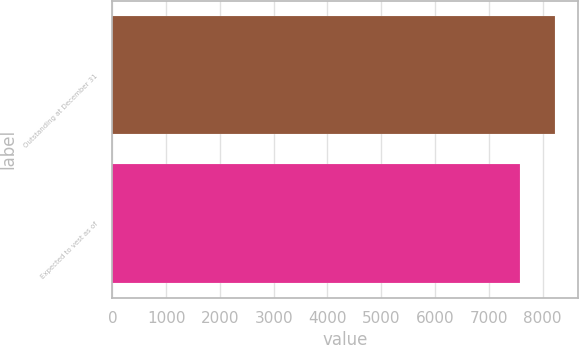Convert chart. <chart><loc_0><loc_0><loc_500><loc_500><bar_chart><fcel>Outstanding at December 31<fcel>Expected to vest as of<nl><fcel>8237<fcel>7577<nl></chart> 